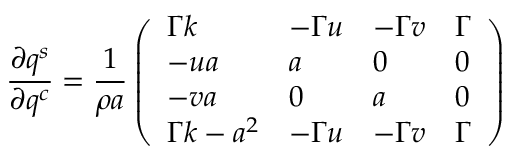Convert formula to latex. <formula><loc_0><loc_0><loc_500><loc_500>\frac { \partial q ^ { s } } { \partial q ^ { c } } = \frac { 1 } { \rho a } \left ( \begin{array} { l l l l } { \Gamma k } & { - \Gamma u } & { - \Gamma v } & { \Gamma } \\ { - u a } & { a } & { 0 } & { 0 } \\ { - v a } & { 0 } & { a } & { 0 } \\ { \Gamma k - a ^ { 2 } } & { - \Gamma u } & { - \Gamma v } & { \Gamma } \end{array} \right )</formula> 